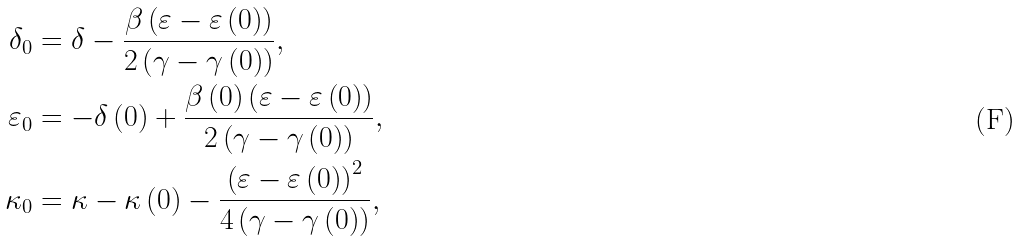<formula> <loc_0><loc_0><loc_500><loc_500>\delta _ { 0 } & = \delta - \frac { \beta \left ( \varepsilon - \varepsilon \left ( 0 \right ) \right ) } { 2 \left ( \gamma - \gamma \left ( 0 \right ) \right ) } , \\ \varepsilon _ { 0 } & = - \delta \left ( 0 \right ) + \frac { \beta \left ( 0 \right ) \left ( \varepsilon - \varepsilon \left ( 0 \right ) \right ) } { 2 \left ( \gamma - \gamma \left ( 0 \right ) \right ) } , \\ \kappa _ { 0 } & = \kappa - \kappa \left ( 0 \right ) - \frac { \left ( \varepsilon - \varepsilon \left ( 0 \right ) \right ) ^ { 2 } } { 4 \left ( \gamma - \gamma \left ( 0 \right ) \right ) } ,</formula> 